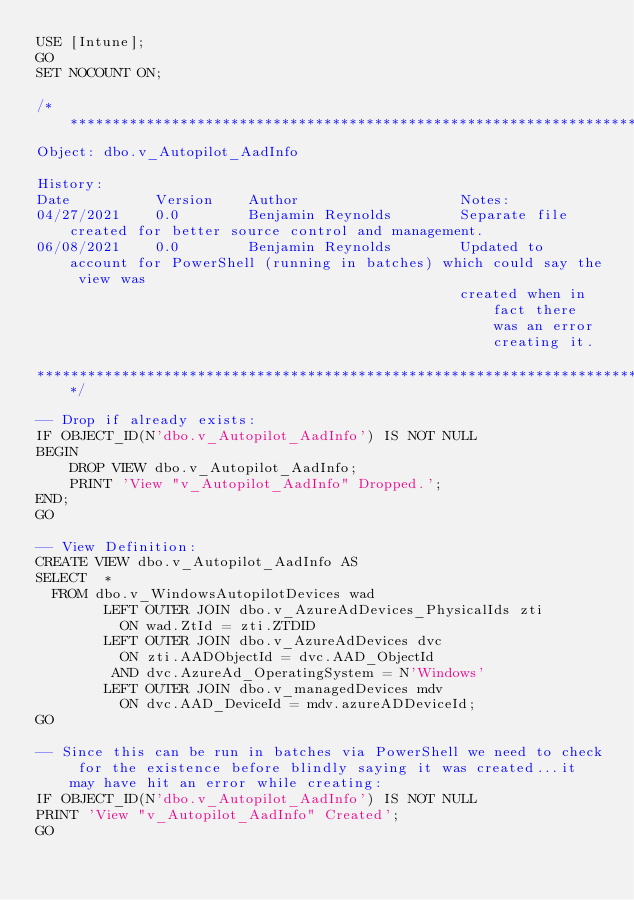Convert code to text. <code><loc_0><loc_0><loc_500><loc_500><_SQL_>USE [Intune];
GO
SET NOCOUNT ON;

/***************************************************************************************************************************
Object: dbo.v_Autopilot_AadInfo

History:
Date          Version    Author                   Notes:
04/27/2021    0.0        Benjamin Reynolds        Separate file created for better source control and management.
06/08/2021    0.0        Benjamin Reynolds        Updated to account for PowerShell (running in batches) which could say the view was
                                                  created when in fact there was an error creating it.

***************************************************************************************************************************/

-- Drop if already exists:
IF OBJECT_ID(N'dbo.v_Autopilot_AadInfo') IS NOT NULL
BEGIN
    DROP VIEW dbo.v_Autopilot_AadInfo;
    PRINT 'View "v_Autopilot_AadInfo" Dropped.';
END;
GO

-- View Definition:
CREATE VIEW dbo.v_Autopilot_AadInfo AS
SELECT  *
  FROM dbo.v_WindowsAutopilotDevices wad
        LEFT OUTER JOIN dbo.v_AzureAdDevices_PhysicalIds zti
          ON wad.ZtId = zti.ZTDID
        LEFT OUTER JOIN dbo.v_AzureAdDevices dvc
          ON zti.AADObjectId = dvc.AAD_ObjectId
         AND dvc.AzureAd_OperatingSystem = N'Windows'
        LEFT OUTER JOIN dbo.v_managedDevices mdv
          ON dvc.AAD_DeviceId = mdv.azureADDeviceId;
GO

-- Since this can be run in batches via PowerShell we need to check for the existence before blindly saying it was created...it may have hit an error while creating:
IF OBJECT_ID(N'dbo.v_Autopilot_AadInfo') IS NOT NULL
PRINT 'View "v_Autopilot_AadInfo" Created';
GO</code> 